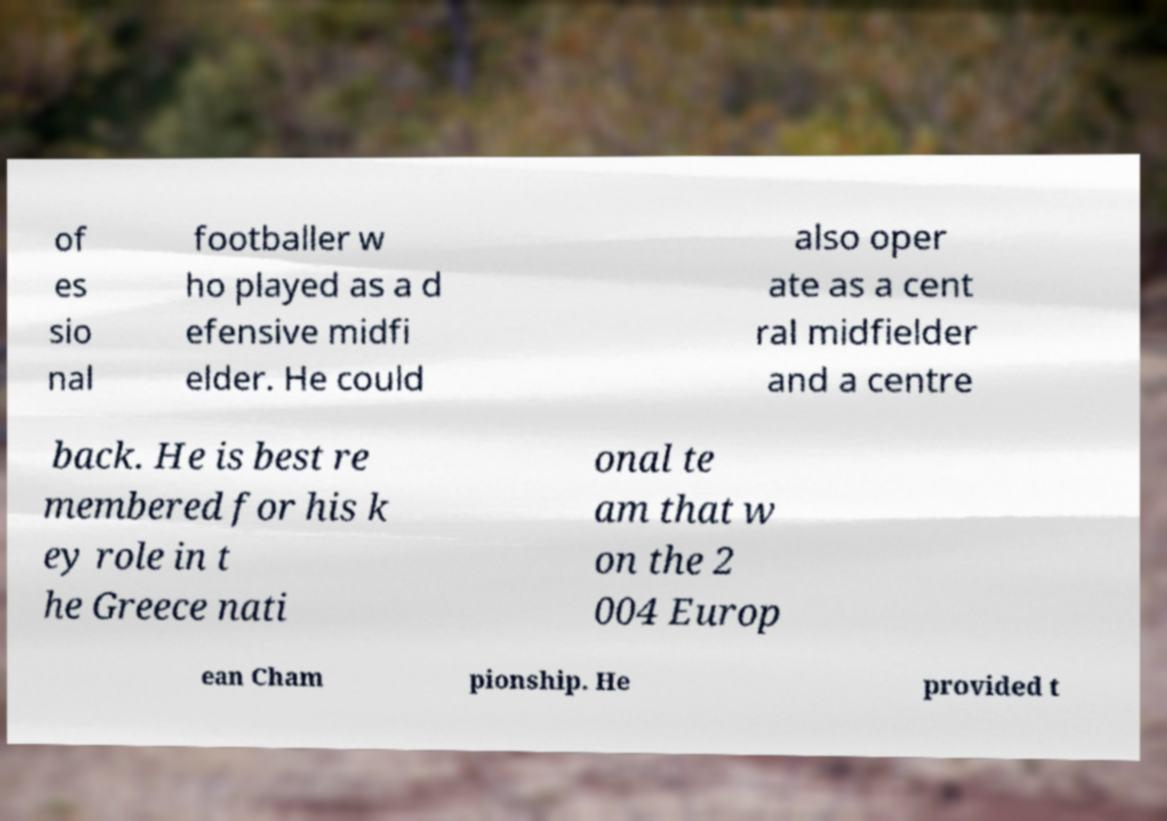For documentation purposes, I need the text within this image transcribed. Could you provide that? of es sio nal footballer w ho played as a d efensive midfi elder. He could also oper ate as a cent ral midfielder and a centre back. He is best re membered for his k ey role in t he Greece nati onal te am that w on the 2 004 Europ ean Cham pionship. He provided t 